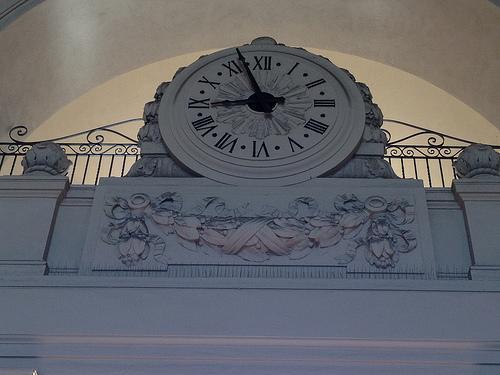How many white columns are pictured?
Give a very brief answer. 2. How many arches are pictured?
Give a very brief answer. 1. 